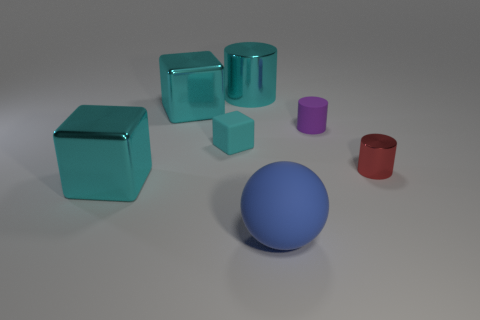Can you tell me about the different colors of objects visible in this scene? Certainly! The image presents a collection of geometric shapes in a variety of colors. There's a prominent cyan group consisting of a large cylinder and two blocks. A single sphere in the center of the composition has a rich blue color. Additionally, there is a purple cylinder and a red cup, each adding their unique hue to the overall palette. 